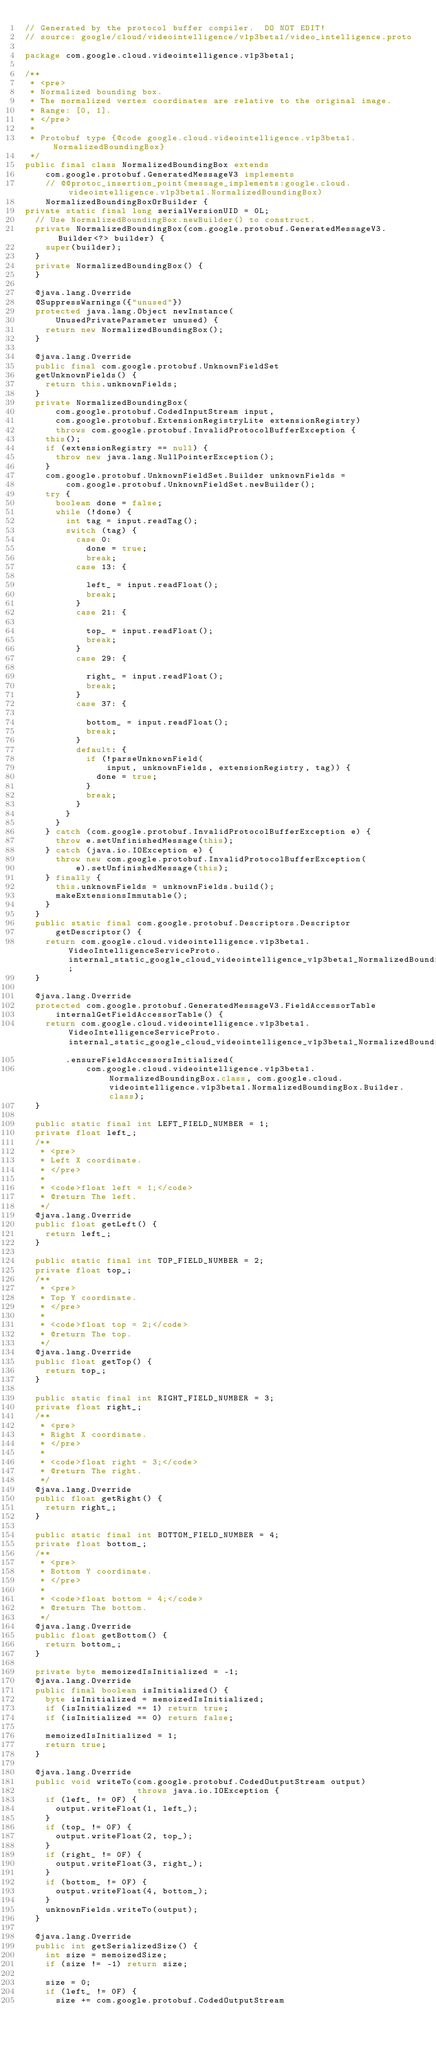Convert code to text. <code><loc_0><loc_0><loc_500><loc_500><_Java_>// Generated by the protocol buffer compiler.  DO NOT EDIT!
// source: google/cloud/videointelligence/v1p3beta1/video_intelligence.proto

package com.google.cloud.videointelligence.v1p3beta1;

/**
 * <pre>
 * Normalized bounding box.
 * The normalized vertex coordinates are relative to the original image.
 * Range: [0, 1].
 * </pre>
 *
 * Protobuf type {@code google.cloud.videointelligence.v1p3beta1.NormalizedBoundingBox}
 */
public final class NormalizedBoundingBox extends
    com.google.protobuf.GeneratedMessageV3 implements
    // @@protoc_insertion_point(message_implements:google.cloud.videointelligence.v1p3beta1.NormalizedBoundingBox)
    NormalizedBoundingBoxOrBuilder {
private static final long serialVersionUID = 0L;
  // Use NormalizedBoundingBox.newBuilder() to construct.
  private NormalizedBoundingBox(com.google.protobuf.GeneratedMessageV3.Builder<?> builder) {
    super(builder);
  }
  private NormalizedBoundingBox() {
  }

  @java.lang.Override
  @SuppressWarnings({"unused"})
  protected java.lang.Object newInstance(
      UnusedPrivateParameter unused) {
    return new NormalizedBoundingBox();
  }

  @java.lang.Override
  public final com.google.protobuf.UnknownFieldSet
  getUnknownFields() {
    return this.unknownFields;
  }
  private NormalizedBoundingBox(
      com.google.protobuf.CodedInputStream input,
      com.google.protobuf.ExtensionRegistryLite extensionRegistry)
      throws com.google.protobuf.InvalidProtocolBufferException {
    this();
    if (extensionRegistry == null) {
      throw new java.lang.NullPointerException();
    }
    com.google.protobuf.UnknownFieldSet.Builder unknownFields =
        com.google.protobuf.UnknownFieldSet.newBuilder();
    try {
      boolean done = false;
      while (!done) {
        int tag = input.readTag();
        switch (tag) {
          case 0:
            done = true;
            break;
          case 13: {

            left_ = input.readFloat();
            break;
          }
          case 21: {

            top_ = input.readFloat();
            break;
          }
          case 29: {

            right_ = input.readFloat();
            break;
          }
          case 37: {

            bottom_ = input.readFloat();
            break;
          }
          default: {
            if (!parseUnknownField(
                input, unknownFields, extensionRegistry, tag)) {
              done = true;
            }
            break;
          }
        }
      }
    } catch (com.google.protobuf.InvalidProtocolBufferException e) {
      throw e.setUnfinishedMessage(this);
    } catch (java.io.IOException e) {
      throw new com.google.protobuf.InvalidProtocolBufferException(
          e).setUnfinishedMessage(this);
    } finally {
      this.unknownFields = unknownFields.build();
      makeExtensionsImmutable();
    }
  }
  public static final com.google.protobuf.Descriptors.Descriptor
      getDescriptor() {
    return com.google.cloud.videointelligence.v1p3beta1.VideoIntelligenceServiceProto.internal_static_google_cloud_videointelligence_v1p3beta1_NormalizedBoundingBox_descriptor;
  }

  @java.lang.Override
  protected com.google.protobuf.GeneratedMessageV3.FieldAccessorTable
      internalGetFieldAccessorTable() {
    return com.google.cloud.videointelligence.v1p3beta1.VideoIntelligenceServiceProto.internal_static_google_cloud_videointelligence_v1p3beta1_NormalizedBoundingBox_fieldAccessorTable
        .ensureFieldAccessorsInitialized(
            com.google.cloud.videointelligence.v1p3beta1.NormalizedBoundingBox.class, com.google.cloud.videointelligence.v1p3beta1.NormalizedBoundingBox.Builder.class);
  }

  public static final int LEFT_FIELD_NUMBER = 1;
  private float left_;
  /**
   * <pre>
   * Left X coordinate.
   * </pre>
   *
   * <code>float left = 1;</code>
   * @return The left.
   */
  @java.lang.Override
  public float getLeft() {
    return left_;
  }

  public static final int TOP_FIELD_NUMBER = 2;
  private float top_;
  /**
   * <pre>
   * Top Y coordinate.
   * </pre>
   *
   * <code>float top = 2;</code>
   * @return The top.
   */
  @java.lang.Override
  public float getTop() {
    return top_;
  }

  public static final int RIGHT_FIELD_NUMBER = 3;
  private float right_;
  /**
   * <pre>
   * Right X coordinate.
   * </pre>
   *
   * <code>float right = 3;</code>
   * @return The right.
   */
  @java.lang.Override
  public float getRight() {
    return right_;
  }

  public static final int BOTTOM_FIELD_NUMBER = 4;
  private float bottom_;
  /**
   * <pre>
   * Bottom Y coordinate.
   * </pre>
   *
   * <code>float bottom = 4;</code>
   * @return The bottom.
   */
  @java.lang.Override
  public float getBottom() {
    return bottom_;
  }

  private byte memoizedIsInitialized = -1;
  @java.lang.Override
  public final boolean isInitialized() {
    byte isInitialized = memoizedIsInitialized;
    if (isInitialized == 1) return true;
    if (isInitialized == 0) return false;

    memoizedIsInitialized = 1;
    return true;
  }

  @java.lang.Override
  public void writeTo(com.google.protobuf.CodedOutputStream output)
                      throws java.io.IOException {
    if (left_ != 0F) {
      output.writeFloat(1, left_);
    }
    if (top_ != 0F) {
      output.writeFloat(2, top_);
    }
    if (right_ != 0F) {
      output.writeFloat(3, right_);
    }
    if (bottom_ != 0F) {
      output.writeFloat(4, bottom_);
    }
    unknownFields.writeTo(output);
  }

  @java.lang.Override
  public int getSerializedSize() {
    int size = memoizedSize;
    if (size != -1) return size;

    size = 0;
    if (left_ != 0F) {
      size += com.google.protobuf.CodedOutputStream</code> 